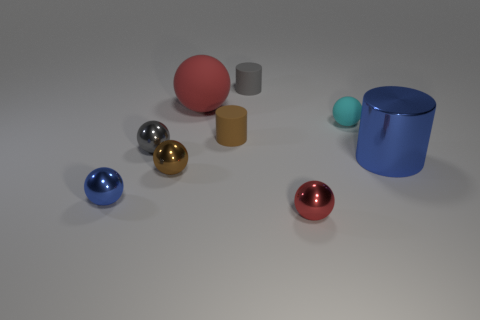Subtract all metallic cylinders. How many cylinders are left? 2 Subtract all cyan spheres. How many spheres are left? 5 Subtract 2 cylinders. How many cylinders are left? 1 Subtract all balls. How many objects are left? 3 Subtract all gray cubes. How many green cylinders are left? 0 Subtract all tiny rubber objects. Subtract all large green cylinders. How many objects are left? 6 Add 7 tiny gray rubber things. How many tiny gray rubber things are left? 8 Add 6 gray metal spheres. How many gray metal spheres exist? 7 Subtract 1 cyan spheres. How many objects are left? 8 Subtract all cyan cylinders. Subtract all gray blocks. How many cylinders are left? 3 